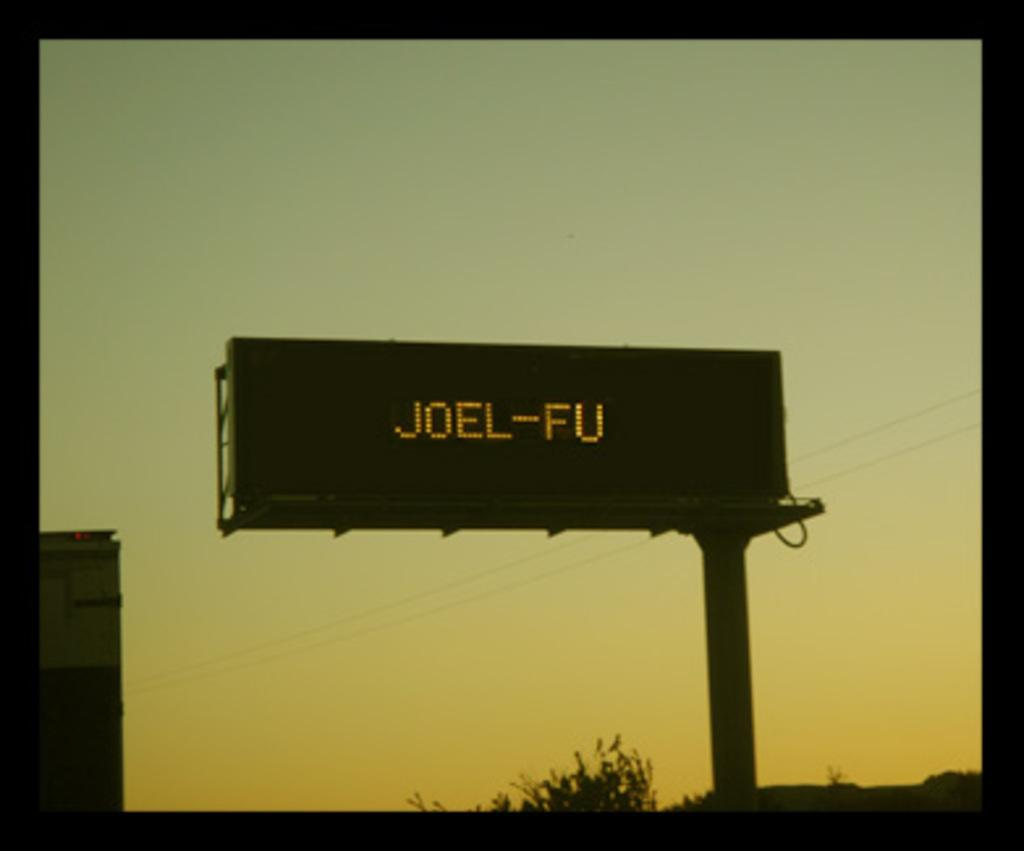<image>
Create a compact narrative representing the image presented. Joel-Fu wrote in yellow on a billboard outside on a pole. 